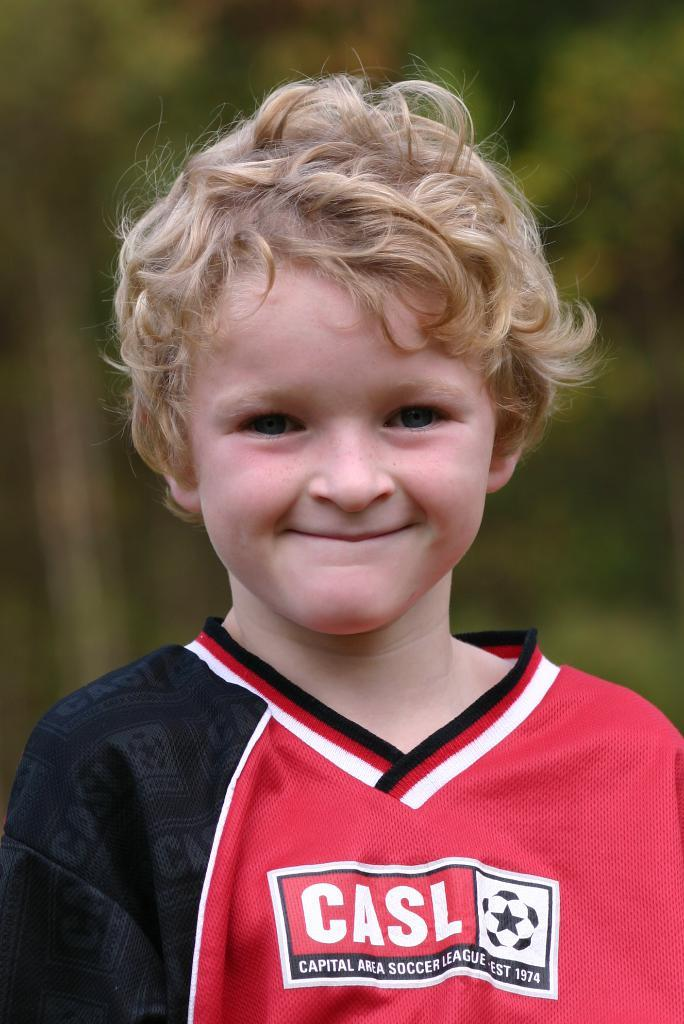<image>
Create a compact narrative representing the image presented. a boy that has the word casl on his soccer jersey 